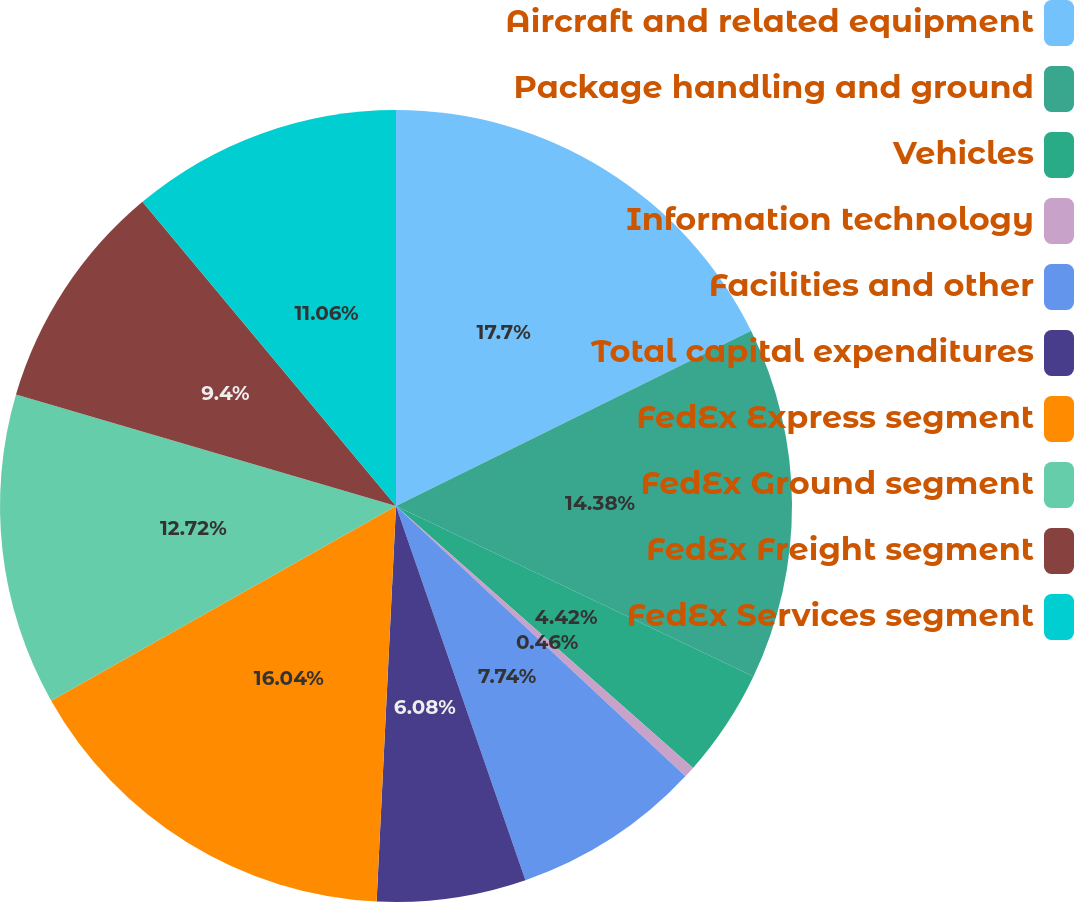Convert chart. <chart><loc_0><loc_0><loc_500><loc_500><pie_chart><fcel>Aircraft and related equipment<fcel>Package handling and ground<fcel>Vehicles<fcel>Information technology<fcel>Facilities and other<fcel>Total capital expenditures<fcel>FedEx Express segment<fcel>FedEx Ground segment<fcel>FedEx Freight segment<fcel>FedEx Services segment<nl><fcel>17.7%<fcel>14.38%<fcel>4.42%<fcel>0.46%<fcel>7.74%<fcel>6.08%<fcel>16.04%<fcel>12.72%<fcel>9.4%<fcel>11.06%<nl></chart> 